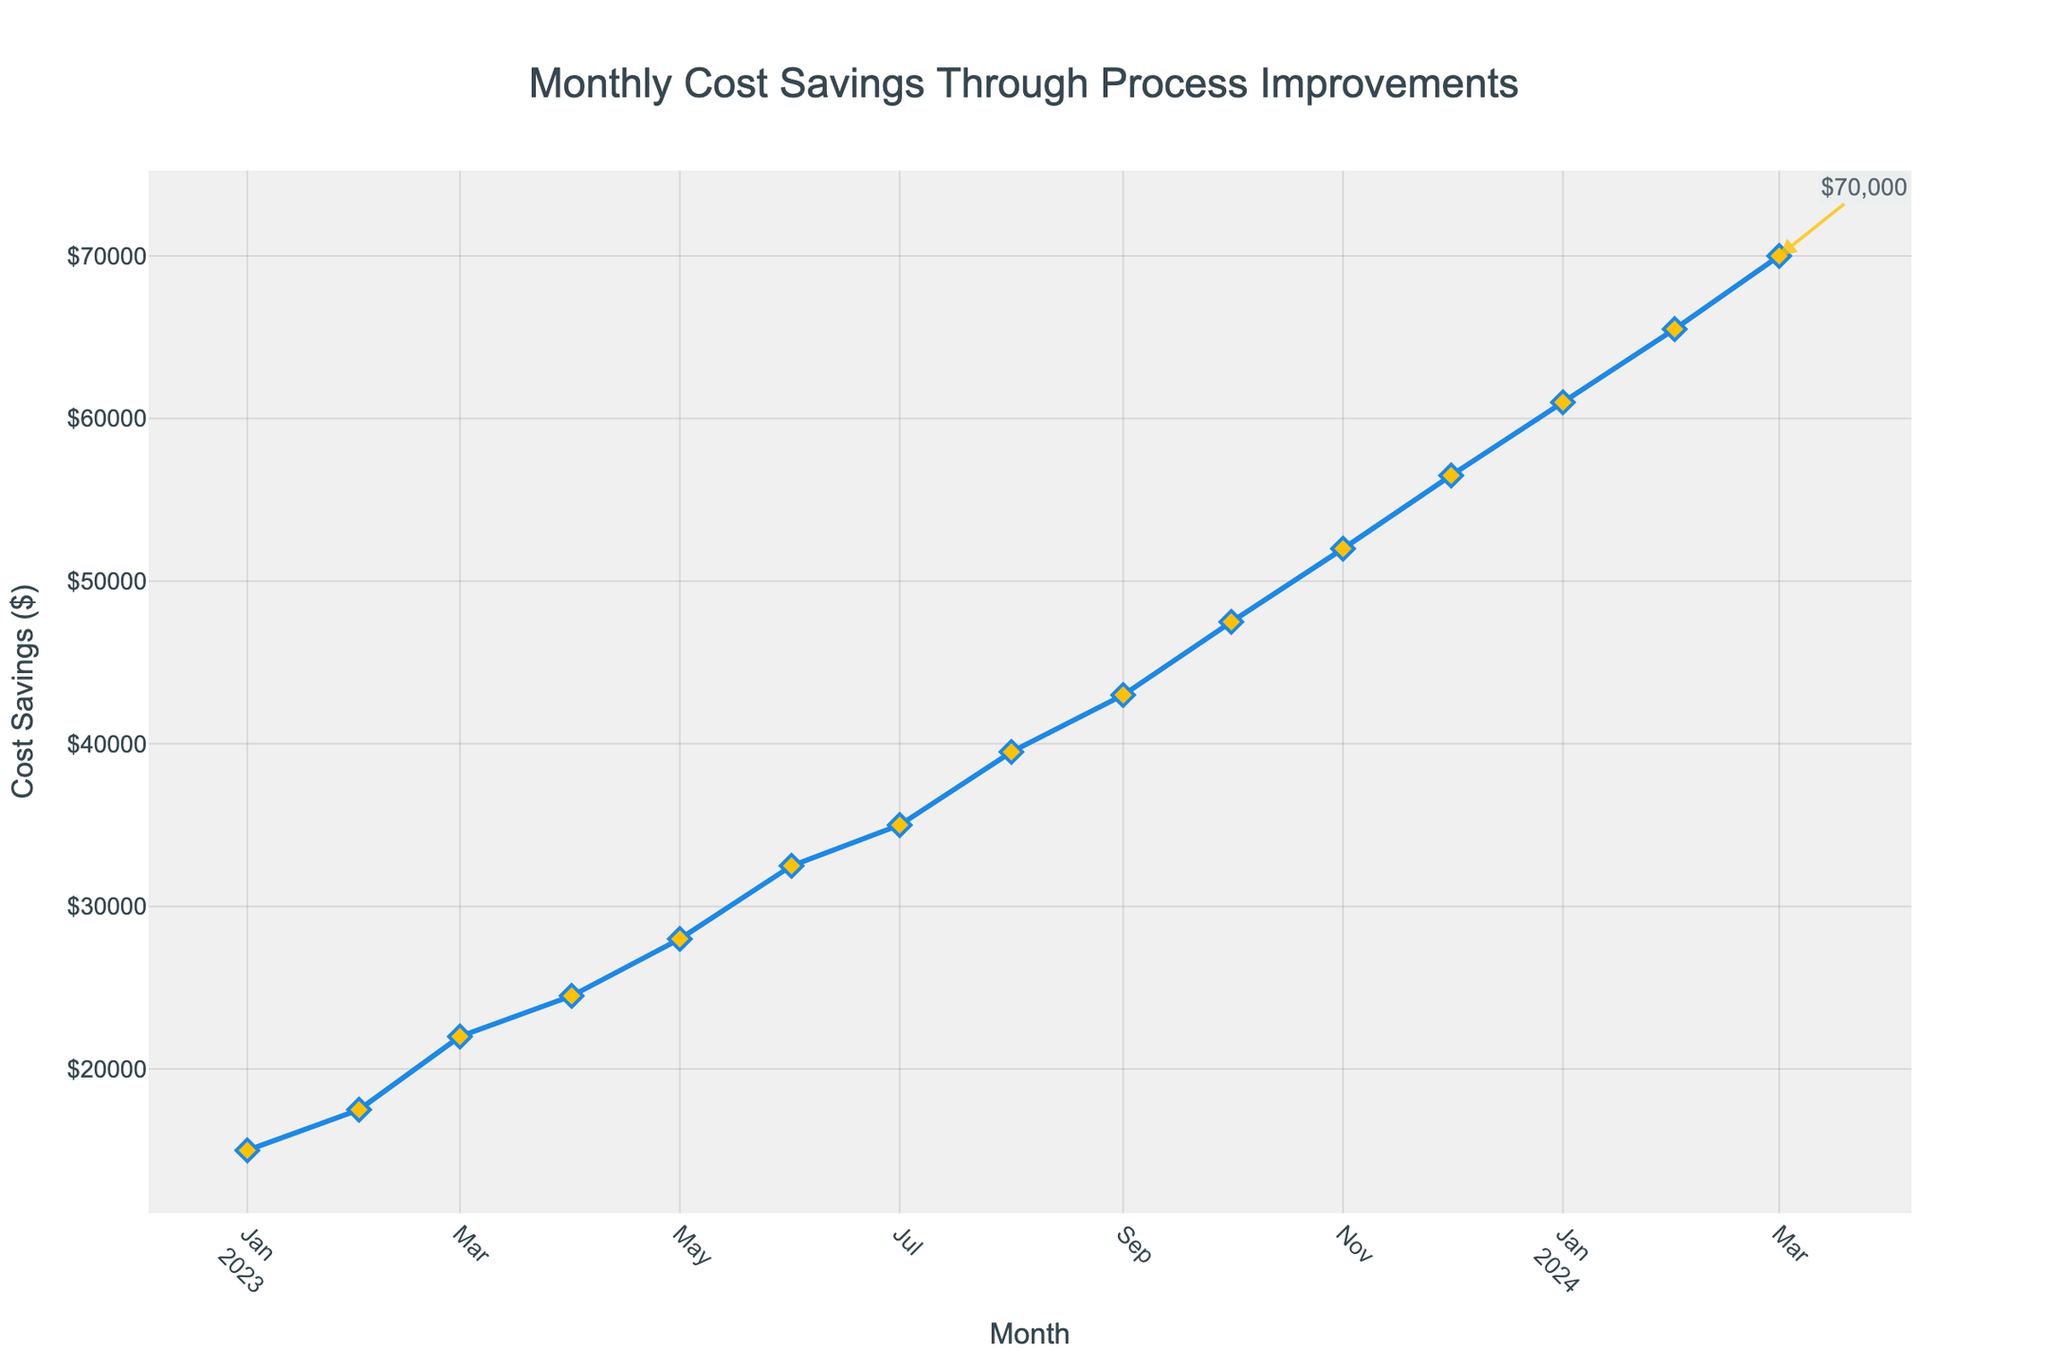What is the total cost savings achieved from Jan 2023 to Dec 2023? To find the total cost savings, sum up the monthly savings from Jan 2023 to Dec 2023: \$15,000 + \$17,500 + \$22,000 + \$24,500 + \$28,000 + \$32,500 + \$35,000 + \$39,500 + \$43,000 + \$47,500 + \$52,000 + \$56,500 = \$413,000
Answer: \$413,000 Which month experienced the highest increase in cost savings compared to the previous month? To identify the month with the highest increase in savings, calculate the difference between consecutive months and find the maximum increase. The differences are: Feb - Jan = \$2,500; Mar - Feb = \$4,500; Apr - Mar = \$2,500; May - Apr = \$3,500; Jun - May = \$4,500; Jul - Jun = \$2,500; Aug - Jul = \$4,500; Sep - Aug = \$3,500; Oct - Sep = \$4,500; Nov - Oct = \$4,500; Dec - Nov = \$4,500; Jan 2024 - Dec = \$4,500; Feb - Jan = \$4,500; Mar - Feb = \$4,500. The highest increase of \$4,500 occurred multiple times.
Answer: Mar 2023, Jun 2023, Aug 2023, Oct 2023, Nov 2023, Dec 2023, Jan 2024, Feb 2024, Mar 2024 What is the average monthly cost savings in 2023? To find the average monthly cost savings for 2023, sum up the cost savings from Jan 2023 to Dec 2023 and divide by 12: \$413,000 / 12 = \$34,416.67
Answer: \$34,416.67 By how much did cost savings increase from Jan 2023 to Jan 2024? To determine the increase, subtract the cost savings in Jan 2023 from Jan 2024: \$61,000 - \$15,000 = \$46,000
Answer: \$46,000 Compared to April 2023, is November 2023's cost savings higher or lower? By how much? Compare the cost savings in April 2023 and November 2023: \$52,000 (Nov) - \$24,500 (Apr) = \$27,500. November's cost savings are higher by \$27,500.
Answer: Higher by \$27,500 What is the average monthly increase in cost savings between consecutive months from Jan 2023 to Mar 2024? Calculate the difference between each consecutive month, sum these differences, and divide by the number of intervals (15): (\$2,500 + \$4,500 + \$2,500 + \$3,500 + \$4,500 + \$2,500 + \$4,500 + \$3,500 + \$4,500 + \$4,500 + \$4,500 + \$4,500 + \$4,500 + \$4,500 + \$4,500) / 15 = \$3,933.33
Answer: \$3,933.33 Which month recorded the lowest cost savings, and what was the amount? The lowest cost savings are in Jan 2023: \$15,000
Answer: Jan 2023, \$15,000 